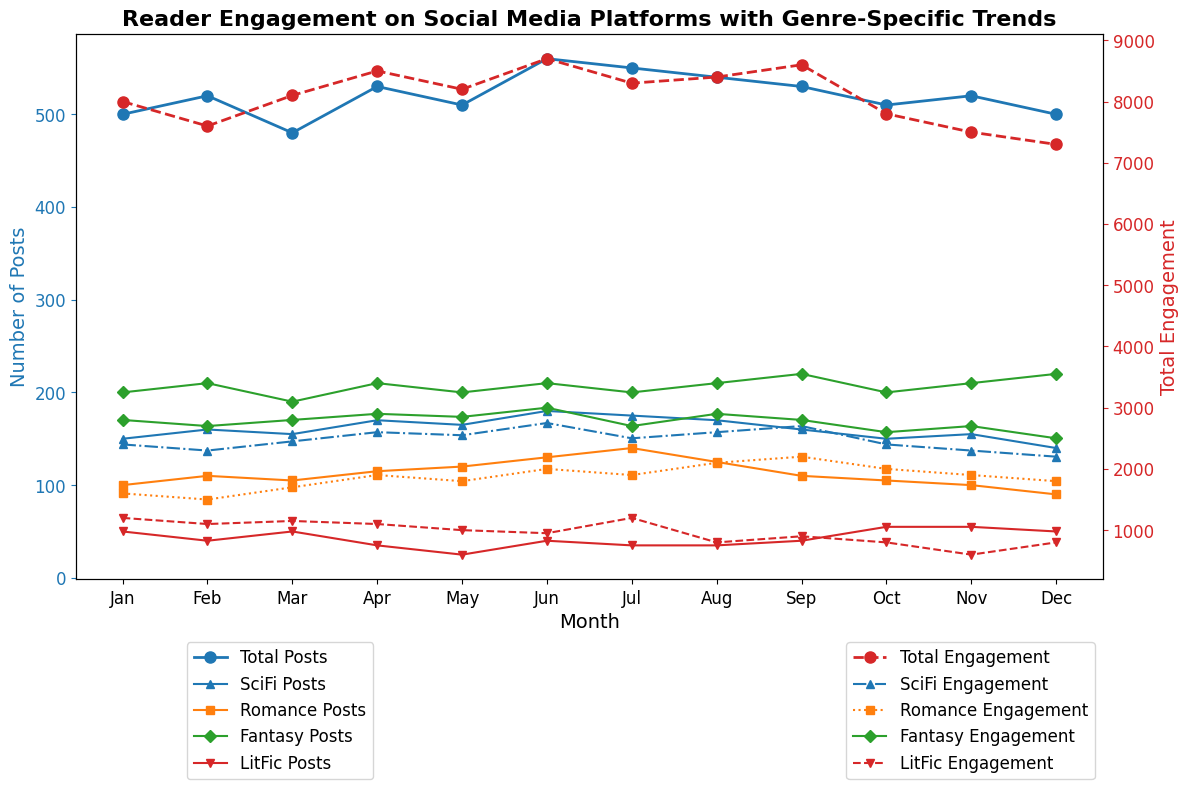What's the trend for Total Posts over the months? By looking at the blue line with circular markers on the left axis, observe the overall direction. If it generally moves upwards or downwards, it indicates the trend. The Total Posts fluctuate up and down across the months.
Answer: Fluctuating How does the engagement for SciFi posts compare to Romance posts in July? Look for the red dashed line (Total Engagement for SciFi) and the green dash-dotted line (Total Engagement for Romance) in July. Compare their positions and values. SciFi engagement (2500) is higher than Romance engagement (1900) in July.
Answer: SciFi is higher What is the highest engagement observed for any genre and in which month does it occur? Identify the highest point across the secondary axis (red markers) for each genre and note the corresponding month. Fantasy has the highest engagement (3000) which occurs in June.
Answer: Fantasy in June Which month has the lowest number of LitFic posts? Follow the LitFic Posts line (identified by the inverted triangle markers on the left axis), and find the lowest point. The lowest number of LitFic posts are in May with 25 posts.
Answer: May Are there any months where the number of SciFi posts is higher than the total number of posts? Compare the SciFi Posts (indicated by the upward triangle markers) with the Total Posts (blue line with circular markers). Since the Total Posts always include SciFi posts as a subset, SciFi Posts are never higher than Total Posts in any month.
Answer: No What is the average engagement for Fantasy across all months? Sum up all the engagement values for Fantasy and divide by the number of months (12). (2800+2700+2800+2900+2850+3000+2700+2900+2800+2600+2700+2500) / 12 = 28050 / 12 = 2337.5
Answer: 2337.5 During which month is the gap between total posts and total engagement the smallest? Calculate the difference between Total Posts and Total Engagement for each month and find the month with the smallest value. The difference is smallest in March (3300).
Answer: March Which genre shows the most consistent posting pattern over the months? Look at the lines for each genre on the left axis and see which has the least fluctuation. SciFi has the most consistent posting pattern with minimal variation month-to-month.
Answer: SciFi How many months have more than 500 total posts? Count the number of months where the Total Posts (blue line with circular markers) exceeds 500. There are 5 months with more than 500 total posts: Feb, Apr, Jun, Jul, Aug.
Answer: 5 